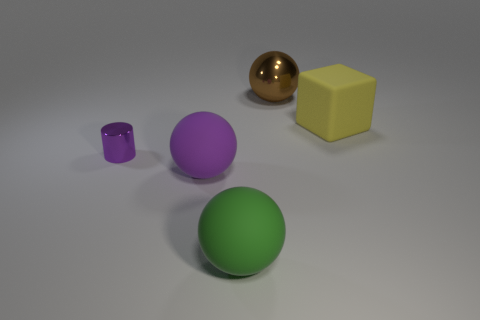What color is the shiny sphere?
Your answer should be very brief. Brown. What is the shape of the thing that is to the right of the large brown metallic object?
Offer a very short reply. Cube. What number of green things are either metallic spheres or large rubber objects?
Ensure brevity in your answer.  1. The other sphere that is the same material as the large green sphere is what color?
Make the answer very short. Purple. Is the color of the cylinder the same as the rubber sphere that is behind the large green rubber thing?
Keep it short and to the point. Yes. What is the color of the thing that is to the left of the big green rubber thing and on the right side of the tiny object?
Give a very brief answer. Purple. There is a small purple shiny thing; how many big balls are in front of it?
Offer a terse response. 2. How many things are small metallic things or large balls that are in front of the large metal ball?
Make the answer very short. 3. There is a large thing that is in front of the big purple rubber thing; is there a yellow matte thing on the right side of it?
Make the answer very short. Yes. What color is the rubber thing in front of the large purple rubber object?
Provide a short and direct response. Green. 